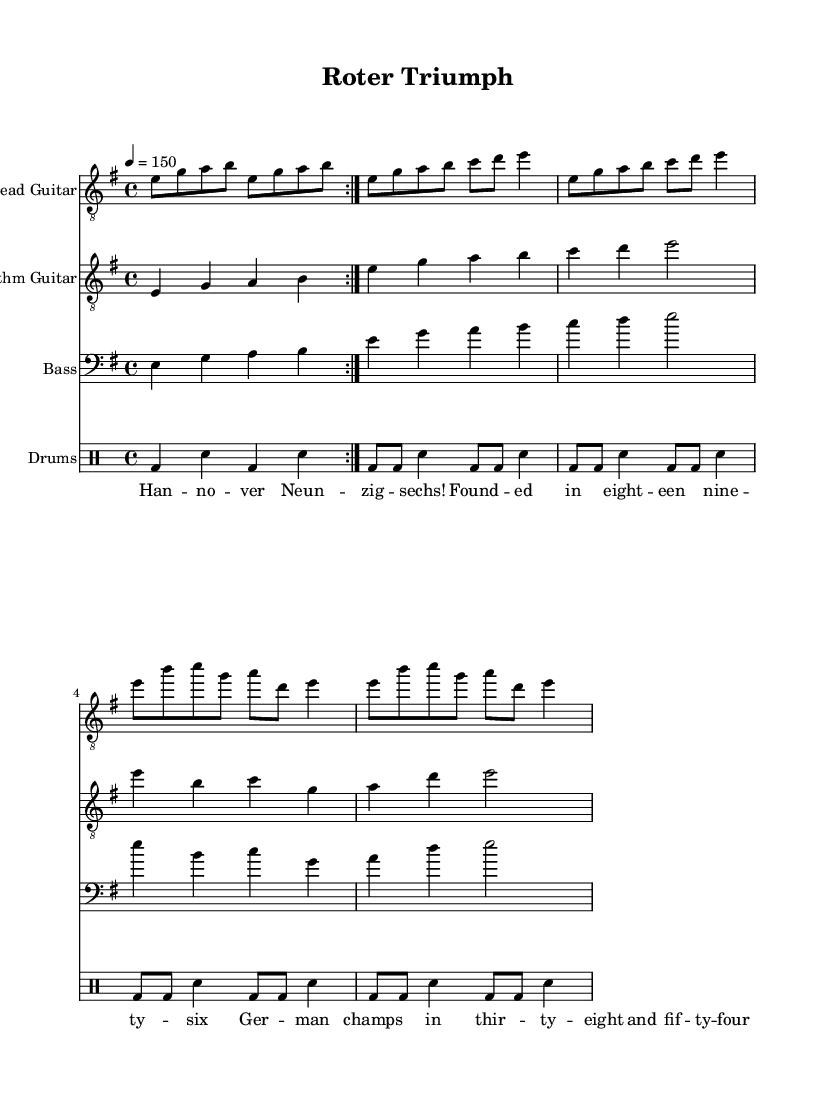What is the key signature of this music? The key signature shows one sharp, indicating that the key of E minor is used.
Answer: E minor What is the time signature of this music? The time signature is displayed at the beginning of the score, showing four beats per measure, which is represented as 4/4.
Answer: 4/4 What is the tempo marking for this piece? The tempo marking indicates a speed of 150 beats per minute, represented as "4 = 150."
Answer: 150 How many times is the lead guitar part repeated? The lead guitar part is indicated to repeat with a volta sign, and it shows the section is to be played twice.
Answer: 2 Which instrument plays the bass part? The bass part is labeled under a staff marked explicitly as "Bass," thus it refers to the bass guitar.
Answer: Bass Guitar What is the lyrical theme of this anthem? The lyrics explicitly mention Hannover 96, referencing its founding year and significant championship years, indicating it celebrates the team.
Answer: Hannover 96 How does the drumming pattern of this piece contribute to its metal genre? The drumming pattern includes typical metal elements such as driving bass drums and snare hits, sustaining a strong pulse suitable for heavy metal.
Answer: Strong pulse 